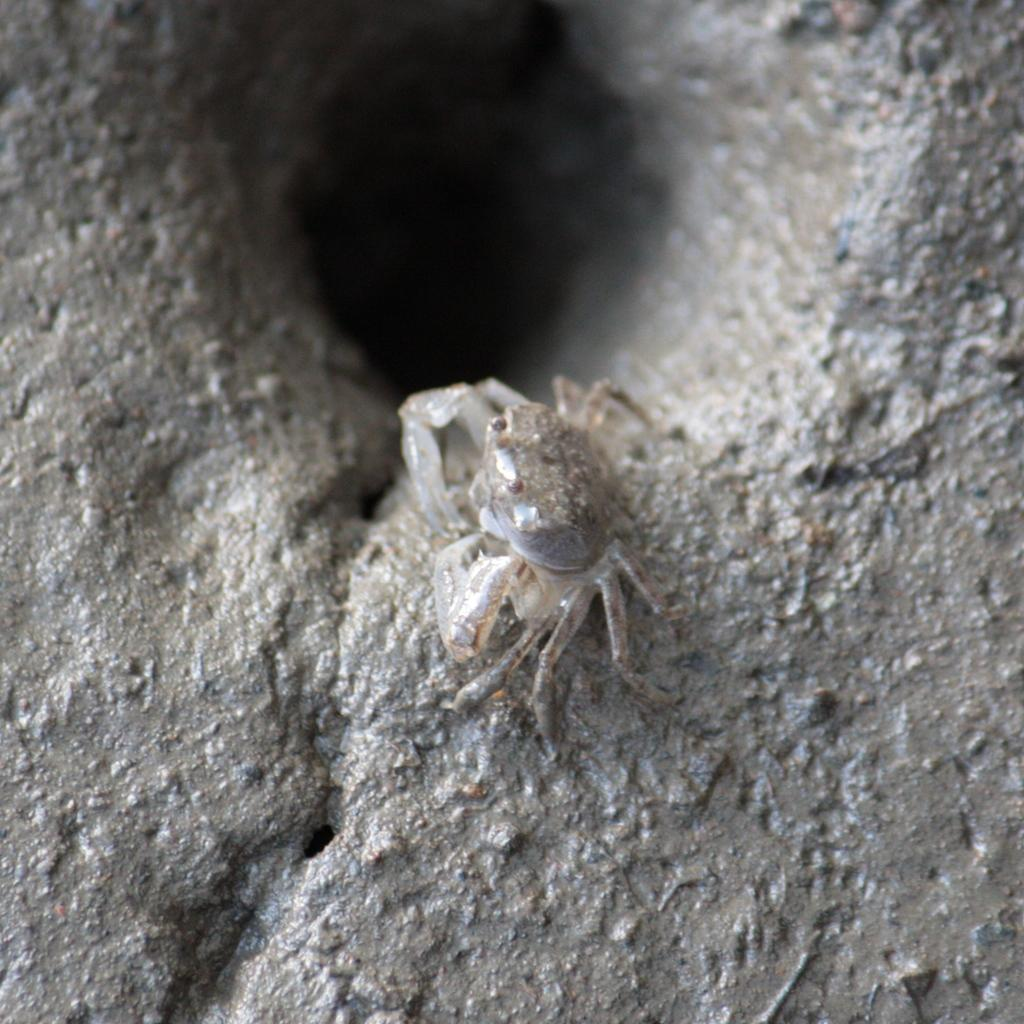What type of animal is in the image? There is a white crab in the image. Where is the crab located in the image? The crab is in the middle of the image. What can be seen in the background of the image? There is a hole in the background of the image. How many passengers are on the train in the image? There is no train present in the image, so it is not possible to determine the number of passengers. 